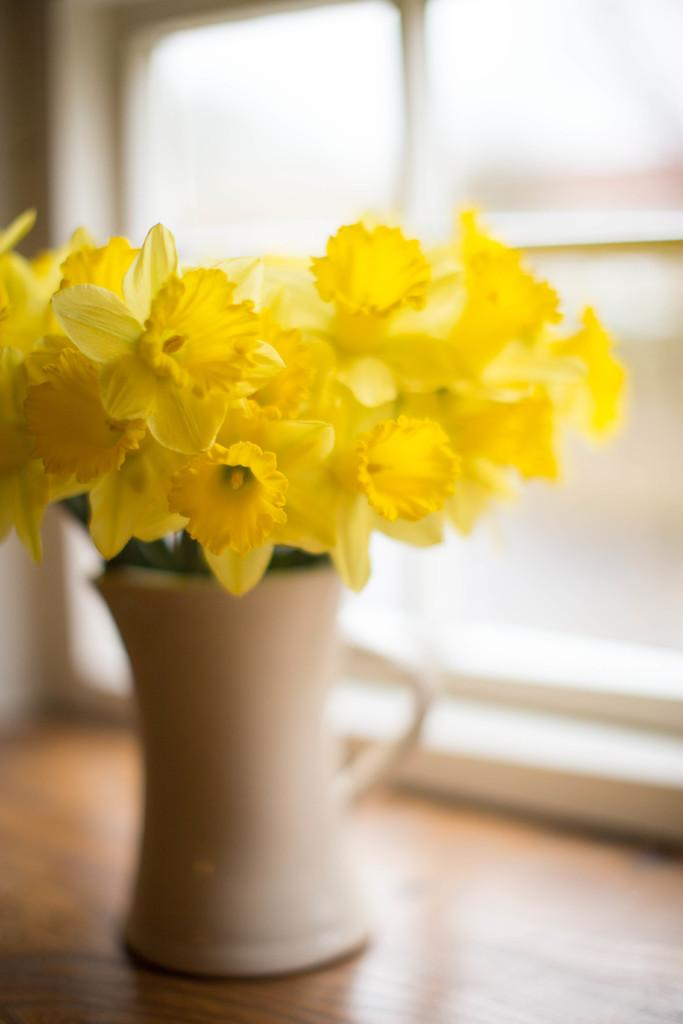What is there is a flower vase on a table in the image, what is the table holding? The table is holding a flower vase. What can be seen through the window in the image? The presence of a window suggests that there might be a view or outdoor scenery visible, but the specifics are not mentioned in the facts. Can you describe the setting of the image? The image may have been taken in a room, as suggested by the presence of a table and window. What type of soda is being served on the sofa in the image? There is no soda or sofa present in the image; it features a flower vase on a table and a window. Can you describe the ship that is sailing in the background of the image? There is no ship present in the image; it features a flower vase on a table and a window. 